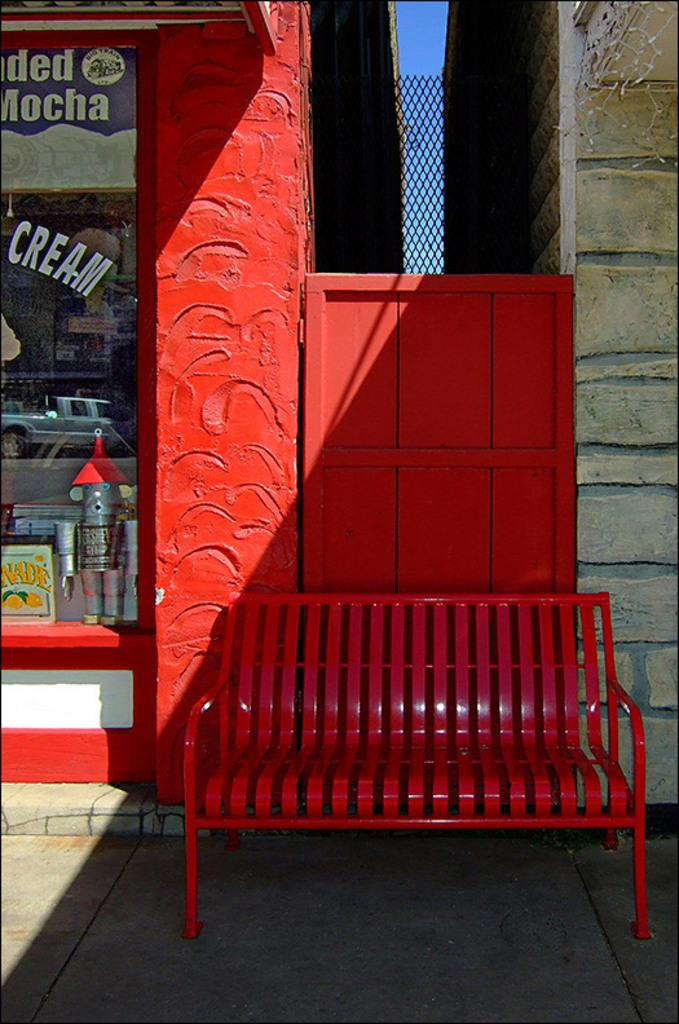What type of furniture is on the floor in the image? There is a bench on the floor in the image. What can be seen in the background of the image? There is a store, a mesh, a wall, and the sky visible in the background. What is on the glass door in the image? There are posters on the glass door in the image. Where are the objects located in the image? The objects are on the left side of the image. What type of nerve is visible in the image? There is no nerve visible in the image; it is a scene featuring a bench, a store, and other elements in the background. 